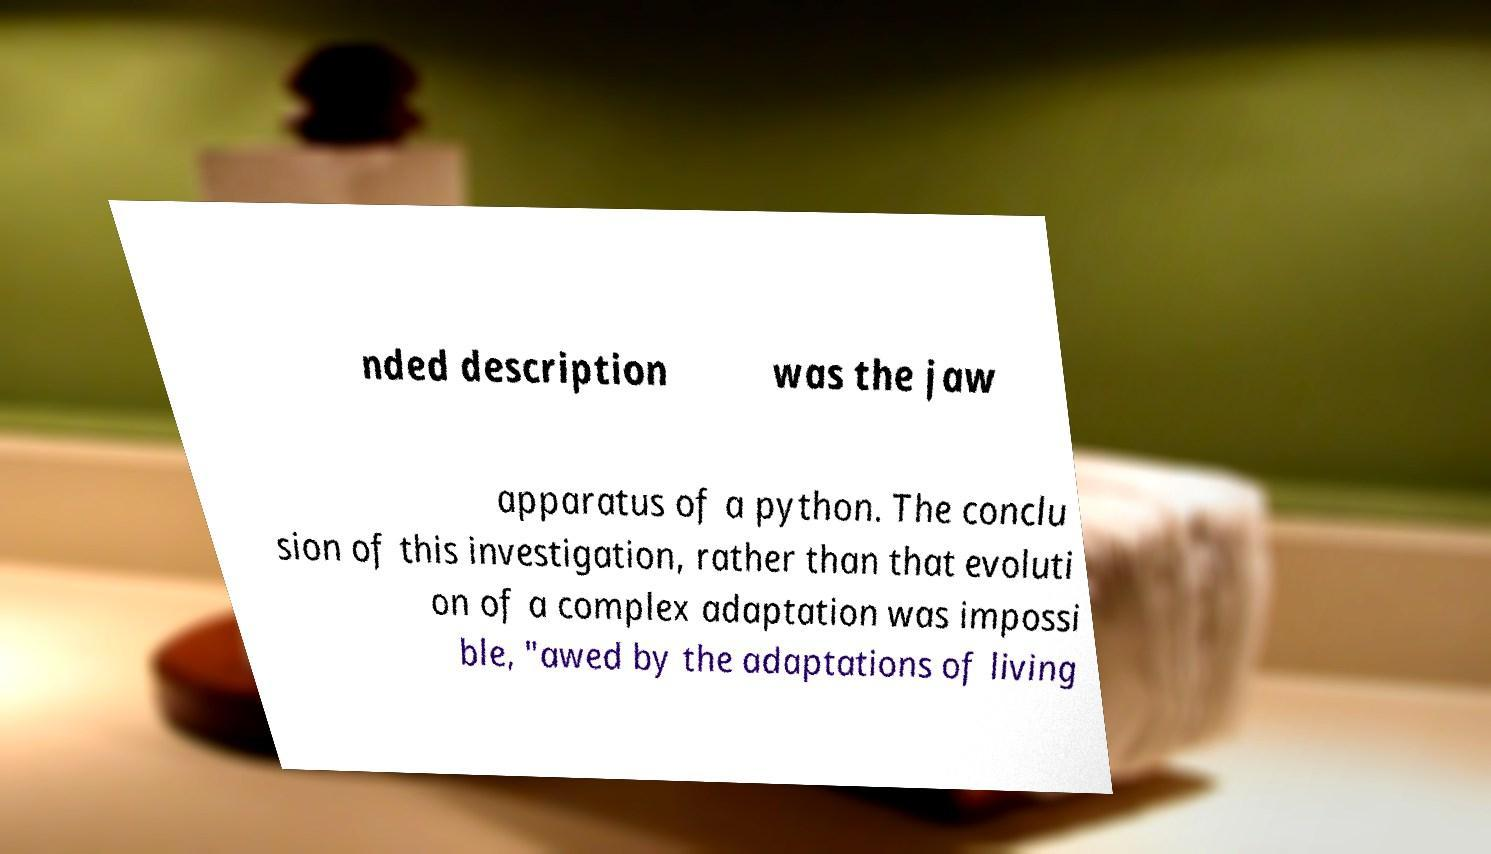There's text embedded in this image that I need extracted. Can you transcribe it verbatim? nded description was the jaw apparatus of a python. The conclu sion of this investigation, rather than that evoluti on of a complex adaptation was impossi ble, "awed by the adaptations of living 